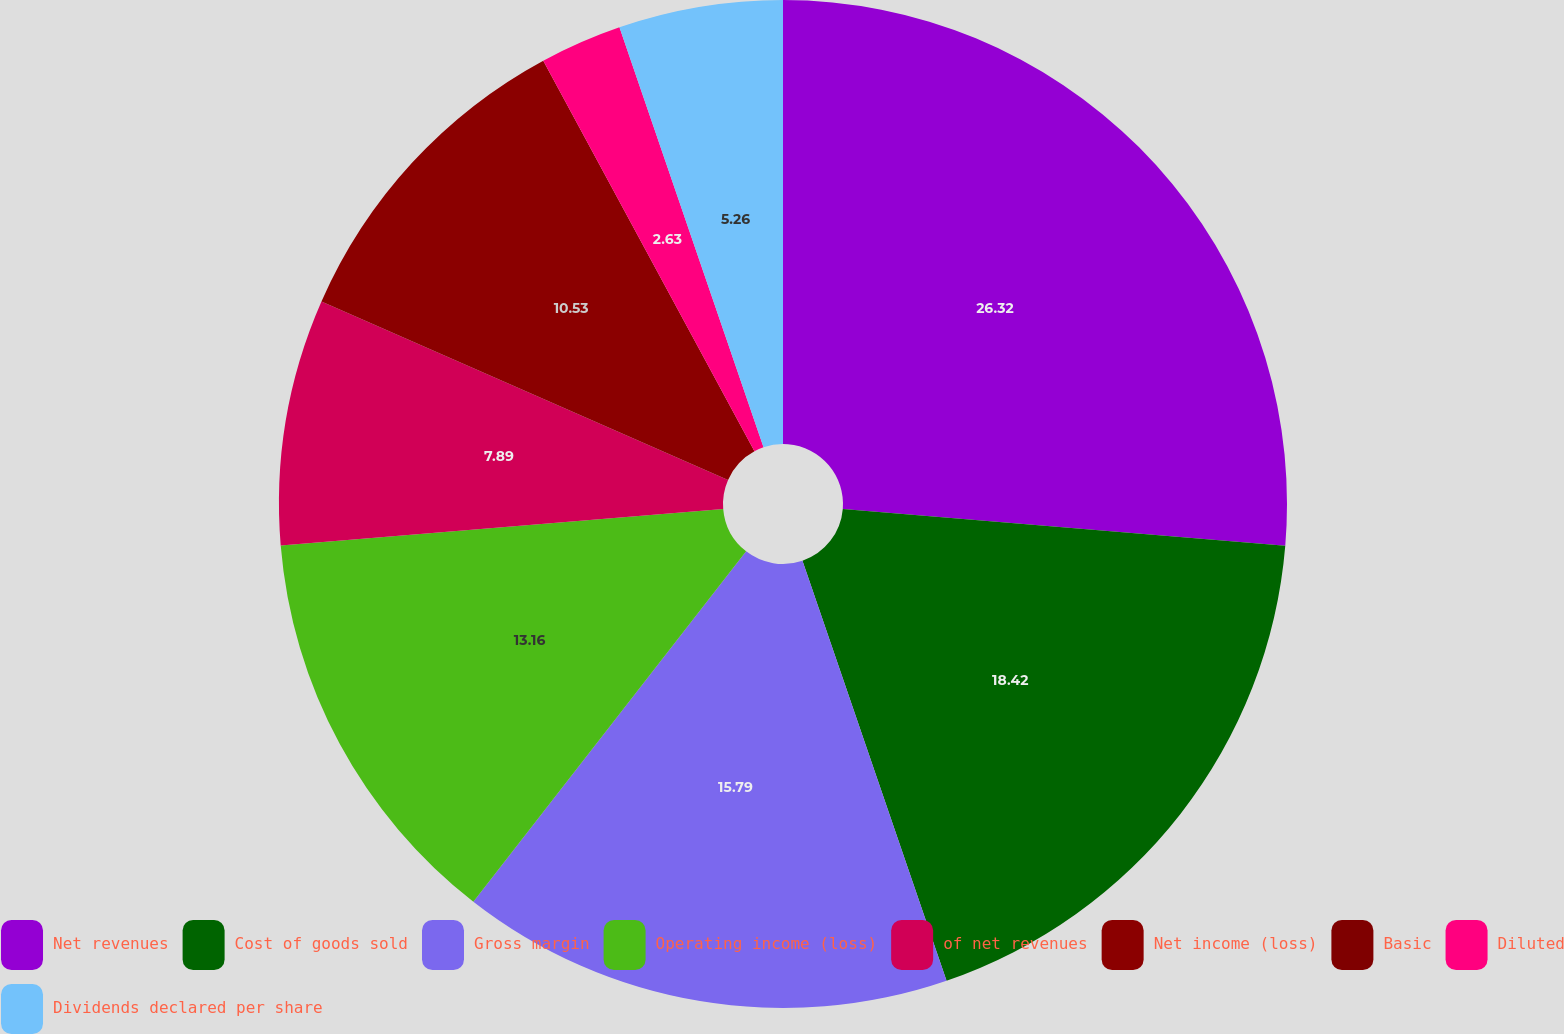Convert chart to OTSL. <chart><loc_0><loc_0><loc_500><loc_500><pie_chart><fcel>Net revenues<fcel>Cost of goods sold<fcel>Gross margin<fcel>Operating income (loss)<fcel>of net revenues<fcel>Net income (loss)<fcel>Basic<fcel>Diluted<fcel>Dividends declared per share<nl><fcel>26.32%<fcel>18.42%<fcel>15.79%<fcel>13.16%<fcel>7.89%<fcel>10.53%<fcel>0.0%<fcel>2.63%<fcel>5.26%<nl></chart> 